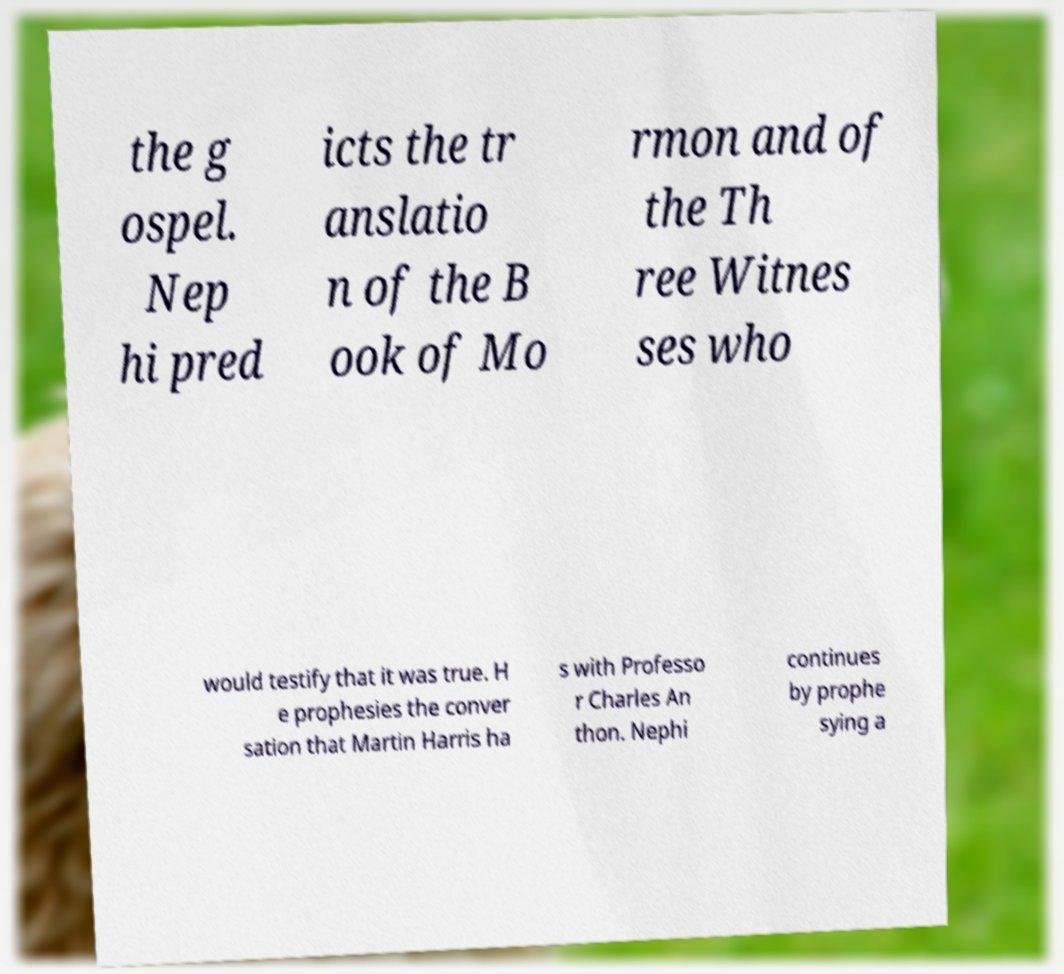For documentation purposes, I need the text within this image transcribed. Could you provide that? the g ospel. Nep hi pred icts the tr anslatio n of the B ook of Mo rmon and of the Th ree Witnes ses who would testify that it was true. H e prophesies the conver sation that Martin Harris ha s with Professo r Charles An thon. Nephi continues by prophe sying a 